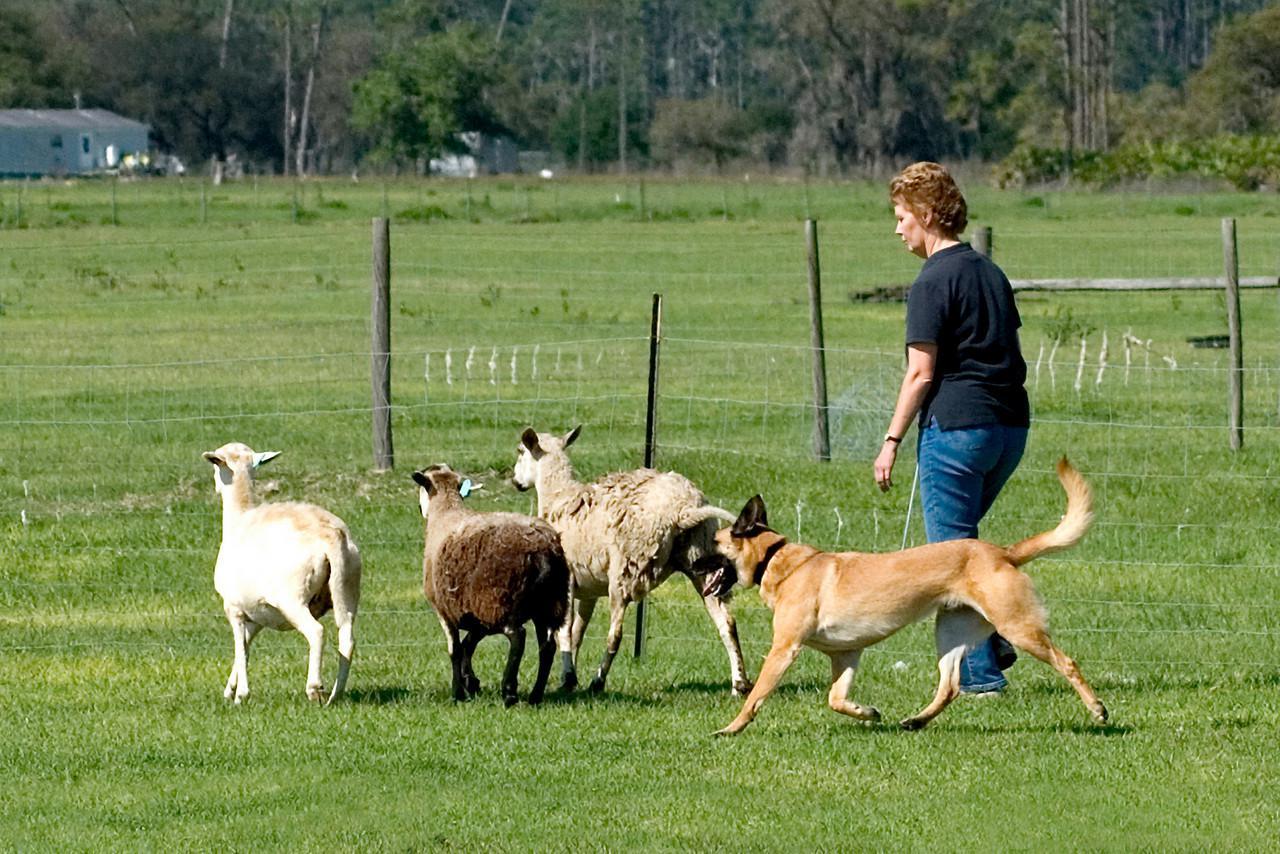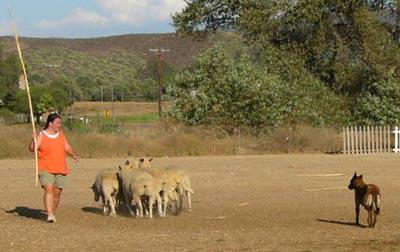The first image is the image on the left, the second image is the image on the right. Analyze the images presented: Is the assertion "All images show a dog with sheep." valid? Answer yes or no. Yes. The first image is the image on the left, the second image is the image on the right. Considering the images on both sides, is "In one image, no livestock are present but at least one dog is visible." valid? Answer yes or no. No. 